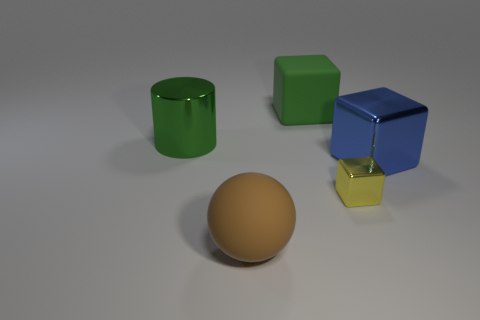Is there anything else that has the same color as the large cylinder?
Offer a terse response. Yes. What size is the object that is behind the blue object and on the right side of the green metallic cylinder?
Make the answer very short. Large. Is the color of the matte object that is right of the matte ball the same as the big metal thing right of the large brown matte ball?
Ensure brevity in your answer.  No. How many other objects are there of the same material as the large brown ball?
Provide a succinct answer. 1. What shape is the big object that is both on the right side of the matte ball and left of the yellow metal cube?
Make the answer very short. Cube. Is the color of the small metal object the same as the big metal thing that is to the right of the tiny thing?
Give a very brief answer. No. There is a green thing that is in front of the green matte cube; is it the same size as the brown sphere?
Your answer should be very brief. Yes. There is a green thing that is the same shape as the large blue shiny thing; what is its material?
Keep it short and to the point. Rubber. Is the large blue thing the same shape as the small yellow thing?
Keep it short and to the point. Yes. There is a matte thing that is on the right side of the large sphere; how many yellow things are behind it?
Keep it short and to the point. 0. 